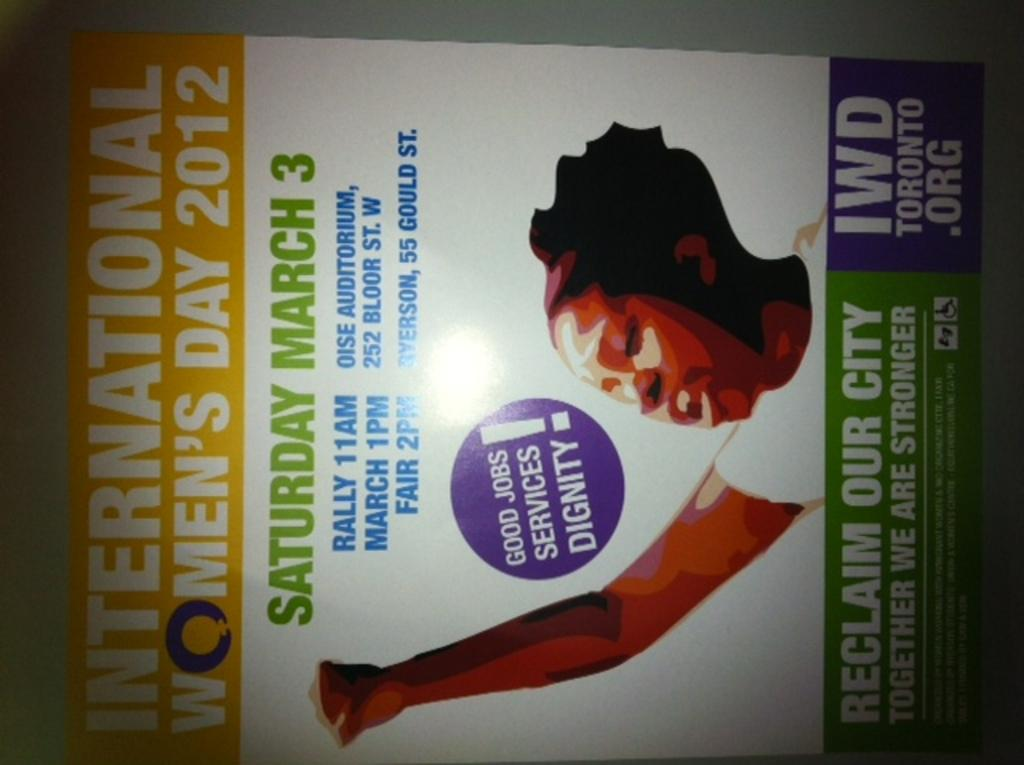What is the main subject of the image? The main subject of the image is a cover page. Who or what is depicted on the cover page? There is a woman on the cover page. What else can be seen on the cover page besides the woman? There is text on the cover page. What colors are used for the text on the cover page? The text is in white, green, and blue colors. How many oranges are visible on the wall in the image? There are no oranges or walls present in the image; it features a cover page with a woman and text. 